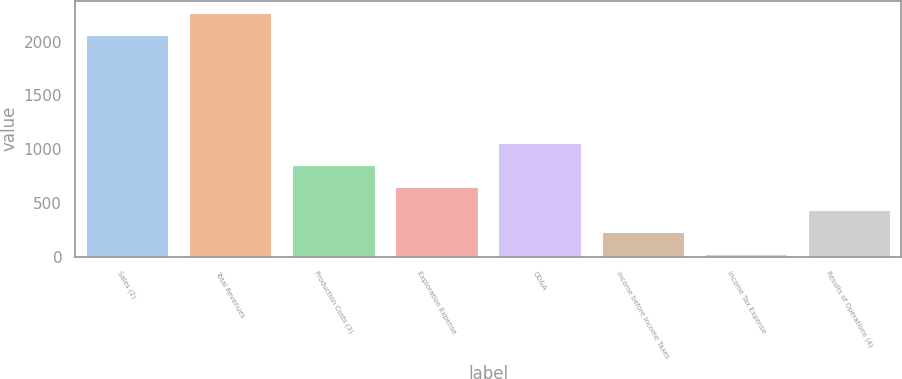Convert chart to OTSL. <chart><loc_0><loc_0><loc_500><loc_500><bar_chart><fcel>Sales (2)<fcel>Total Revenues<fcel>Production Costs (3)<fcel>Exploration Expense<fcel>DD&A<fcel>Income before Income Taxes<fcel>Income Tax Expense<fcel>Results of Operations (4)<nl><fcel>2060<fcel>2267.2<fcel>851.8<fcel>644.6<fcel>1059<fcel>230.2<fcel>23<fcel>437.4<nl></chart> 